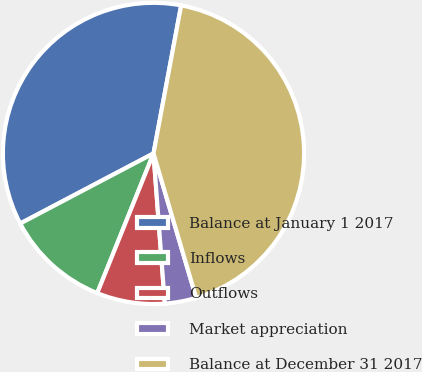<chart> <loc_0><loc_0><loc_500><loc_500><pie_chart><fcel>Balance at January 1 2017<fcel>Inflows<fcel>Outflows<fcel>Market appreciation<fcel>Balance at December 31 2017<nl><fcel>35.65%<fcel>11.2%<fcel>7.29%<fcel>3.38%<fcel>42.49%<nl></chart> 